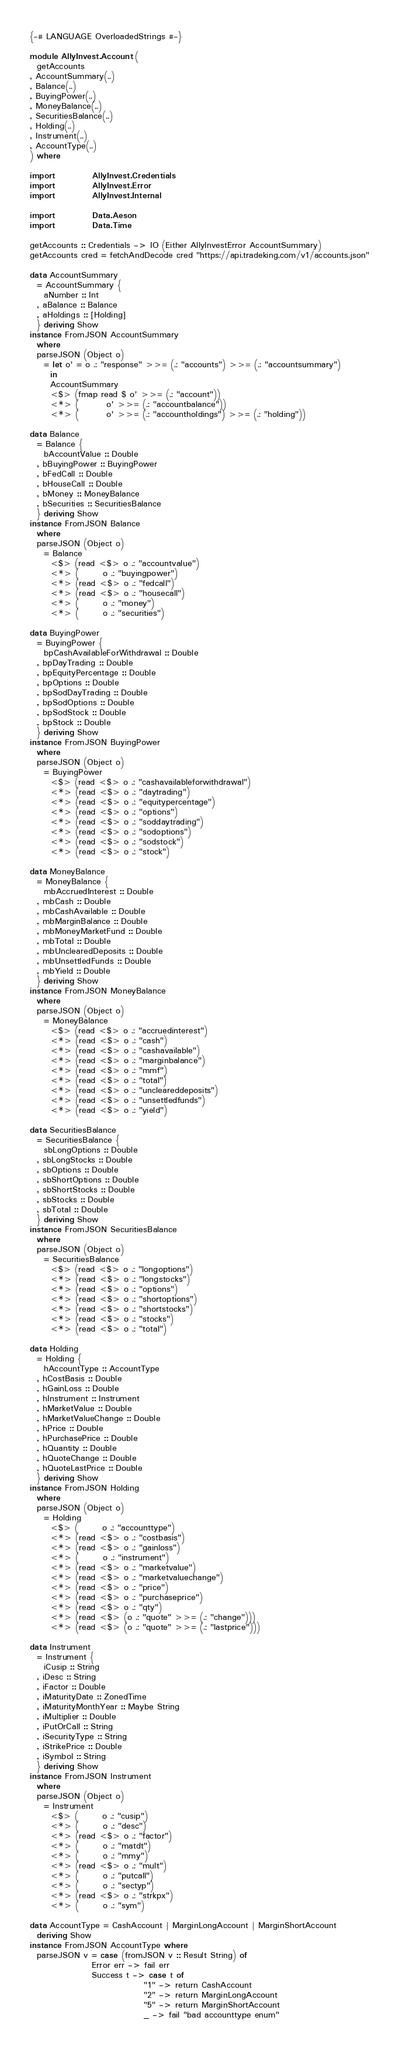Convert code to text. <code><loc_0><loc_0><loc_500><loc_500><_Haskell_>{-# LANGUAGE OverloadedStrings #-}

module AllyInvest.Account (
  getAccounts 
, AccountSummary(..)
, Balance(..)
, BuyingPower(..)
, MoneyBalance(..)
, SecuritiesBalance(..)
, Holding(..)
, Instrument(..)
, AccountType(..)
) where

import           AllyInvest.Credentials
import           AllyInvest.Error
import           AllyInvest.Internal

import           Data.Aeson
import           Data.Time

getAccounts :: Credentials -> IO (Either AllyInvestError AccountSummary)
getAccounts cred = fetchAndDecode cred "https://api.tradeking.com/v1/accounts.json"

data AccountSummary
  = AccountSummary {
    aNumber :: Int
  , aBalance :: Balance
  , aHoldings :: [Holding]
  } deriving Show
instance FromJSON AccountSummary
  where
  parseJSON (Object o)
    = let o' = o .: "response" >>= (.: "accounts") >>= (.: "accountsummary")
      in
      AccountSummary
      <$> (fmap read $ o' >>= (.: "account"))
      <*> (        o' >>= (.: "accountbalance"))
      <*> (        o' >>= (.: "accountholdings") >>= (.: "holding"))

data Balance
  = Balance {
    bAccountValue :: Double
  , bBuyingPower :: BuyingPower
  , bFedCall :: Double
  , bHouseCall :: Double
  , bMoney :: MoneyBalance
  , bSecurities :: SecuritiesBalance
  } deriving Show
instance FromJSON Balance
  where
  parseJSON (Object o)
    = Balance
      <$> (read <$> o .: "accountvalue")
      <*> (       o .: "buyingpower")
      <*> (read <$> o .: "fedcall")
      <*> (read <$> o .: "housecall")
      <*> (       o .: "money")
      <*> (       o .: "securities")

data BuyingPower
  = BuyingPower {
    bpCashAvailableForWithdrawal :: Double
  , bpDayTrading :: Double
  , bpEquityPercentage :: Double
  , bpOptions :: Double
  , bpSodDayTrading :: Double
  , bpSodOptions :: Double
  , bpSodStock :: Double
  , bpStock :: Double
  } deriving Show
instance FromJSON BuyingPower
  where
  parseJSON (Object o)
    = BuyingPower
      <$> (read <$> o .: "cashavailableforwithdrawal")
      <*> (read <$> o .: "daytrading")
      <*> (read <$> o .: "equitypercentage")
      <*> (read <$> o .: "options")
      <*> (read <$> o .: "soddaytrading")
      <*> (read <$> o .: "sodoptions")
      <*> (read <$> o .: "sodstock")
      <*> (read <$> o .: "stock")

data MoneyBalance
  = MoneyBalance {
    mbAccruedInterest :: Double
  , mbCash :: Double
  , mbCashAvailable :: Double
  , mbMarginBalance :: Double
  , mbMoneyMarketFund :: Double
  , mbTotal :: Double
  , mbUnclearedDeposits :: Double
  , mbUnsettledFunds :: Double
  , mbYield :: Double
  } deriving Show
instance FromJSON MoneyBalance
  where
  parseJSON (Object o)
    = MoneyBalance
      <$> (read <$> o .: "accruedinterest")
      <*> (read <$> o .: "cash")
      <*> (read <$> o .: "cashavailable")
      <*> (read <$> o .: "marginbalance")
      <*> (read <$> o .: "mmf")
      <*> (read <$> o .: "total")
      <*> (read <$> o .: "uncleareddeposits")
      <*> (read <$> o .: "unsettledfunds")
      <*> (read <$> o .: "yield")

data SecuritiesBalance
  = SecuritiesBalance {
    sbLongOptions :: Double
  , sbLongStocks :: Double
  , sbOptions :: Double
  , sbShortOptions :: Double
  , sbShortStocks :: Double
  , sbStocks :: Double
  , sbTotal :: Double
  } deriving Show
instance FromJSON SecuritiesBalance
  where
  parseJSON (Object o)
    = SecuritiesBalance
      <$> (read <$> o .: "longoptions")
      <*> (read <$> o .: "longstocks")
      <*> (read <$> o .: "options")
      <*> (read <$> o .: "shortoptions")
      <*> (read <$> o .: "shortstocks")
      <*> (read <$> o .: "stocks")
      <*> (read <$> o .: "total")

data Holding
  = Holding {
    hAccountType :: AccountType
  , hCostBasis :: Double
  , hGainLoss :: Double
  , hInstrument :: Instrument
  , hMarketValue :: Double
  , hMarketValueChange :: Double
  , hPrice :: Double
  , hPurchasePrice :: Double
  , hQuantity :: Double
  , hQuoteChange :: Double
  , hQuoteLastPrice :: Double
  } deriving Show
instance FromJSON Holding
  where
  parseJSON (Object o)
    = Holding
      <$> (       o .: "accounttype")
      <*> (read <$> o .: "costbasis")
      <*> (read <$> o .: "gainloss")
      <*> (       o .: "instrument")
      <*> (read <$> o .: "marketvalue")
      <*> (read <$> o .: "marketvaluechange")
      <*> (read <$> o .: "price")
      <*> (read <$> o .: "purchaseprice")
      <*> (read <$> o .: "qty")
      <*> (read <$> (o .: "quote" >>= (.: "change")))
      <*> (read <$> (o .: "quote" >>= (.: "lastprice")))

data Instrument
  = Instrument {
    iCusip :: String
  , iDesc :: String
  , iFactor :: Double
  , iMaturityDate :: ZonedTime
  , iMaturityMonthYear :: Maybe String
  , iMultiplier :: Double
  , iPutOrCall :: String
  , iSecurityType :: String
  , iStrikePrice :: Double
  , iSymbol :: String
  } deriving Show
instance FromJSON Instrument
  where
  parseJSON (Object o)
    = Instrument
      <$> (       o .: "cusip")
      <*> (       o .: "desc")
      <*> (read <$> o .: "factor")
      <*> (       o .: "matdt")
      <*> (       o .: "mmy")
      <*> (read <$> o .: "mult")
      <*> (       o .: "putcall")
      <*> (       o .: "sectyp")
      <*> (read <$> o .: "strkpx")
      <*> (       o .: "sym")

data AccountType = CashAccount | MarginLongAccount | MarginShortAccount
  deriving Show
instance FromJSON AccountType where
  parseJSON v = case (fromJSON v :: Result String) of
                  Error err -> fail err
                  Success t -> case t of
                                 "1" -> return CashAccount
                                 "2" -> return MarginLongAccount
                                 "5" -> return MarginShortAccount
                                 _ -> fail "bad accounttype enum"
</code> 